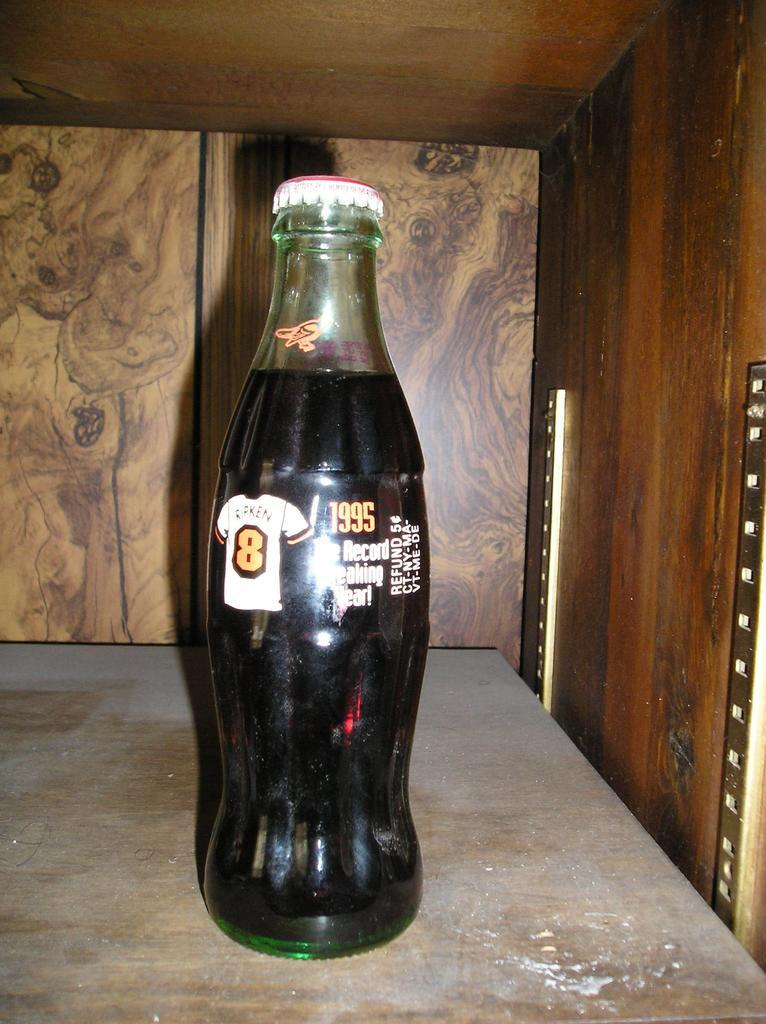What object is present on the wooden table in the image? There is a glass bottle on the wooden table in the image. What type of operation is being performed on the glass bottle in the image? There is no operation being performed on the glass bottle in the image; it is simply sitting on the wooden table. 